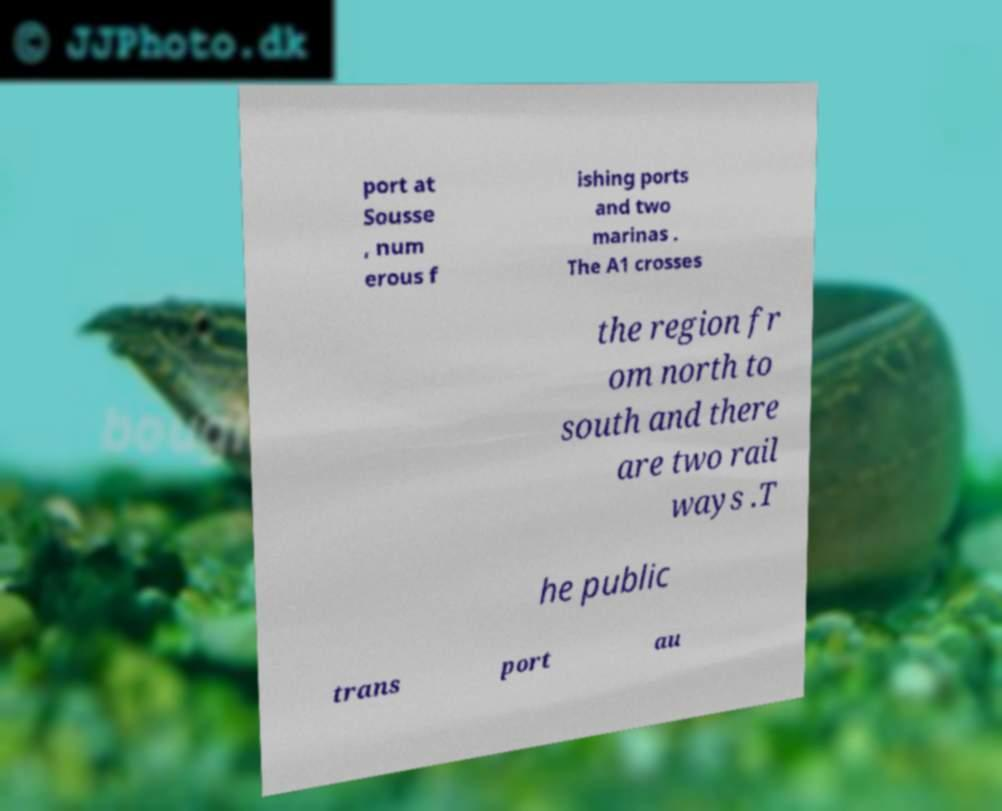Please read and relay the text visible in this image. What does it say? port at Sousse , num erous f ishing ports and two marinas . The A1 crosses the region fr om north to south and there are two rail ways .T he public trans port au 